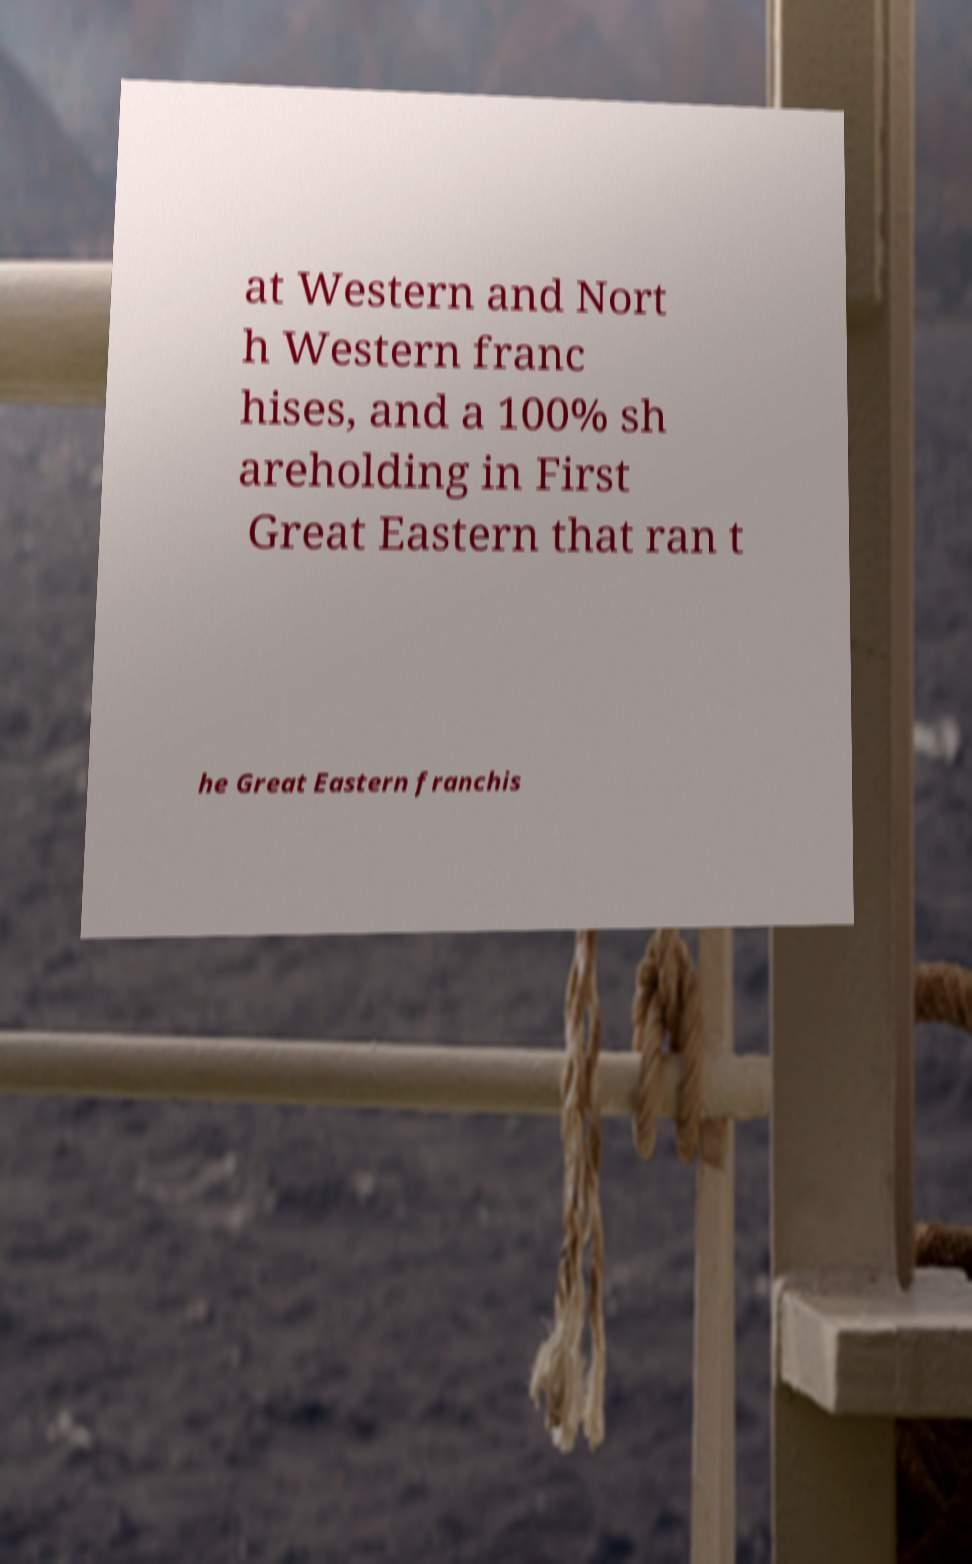Can you read and provide the text displayed in the image?This photo seems to have some interesting text. Can you extract and type it out for me? at Western and Nort h Western franc hises, and a 100% sh areholding in First Great Eastern that ran t he Great Eastern franchis 